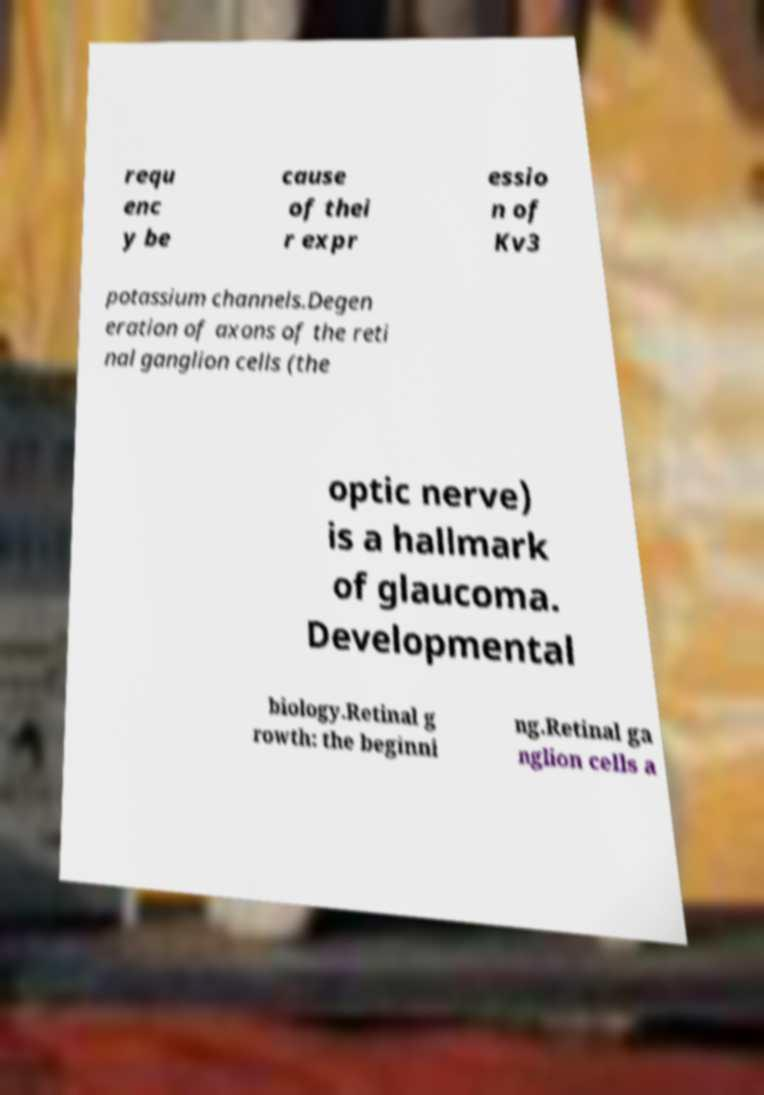Could you extract and type out the text from this image? requ enc y be cause of thei r expr essio n of Kv3 potassium channels.Degen eration of axons of the reti nal ganglion cells (the optic nerve) is a hallmark of glaucoma. Developmental biology.Retinal g rowth: the beginni ng.Retinal ga nglion cells a 